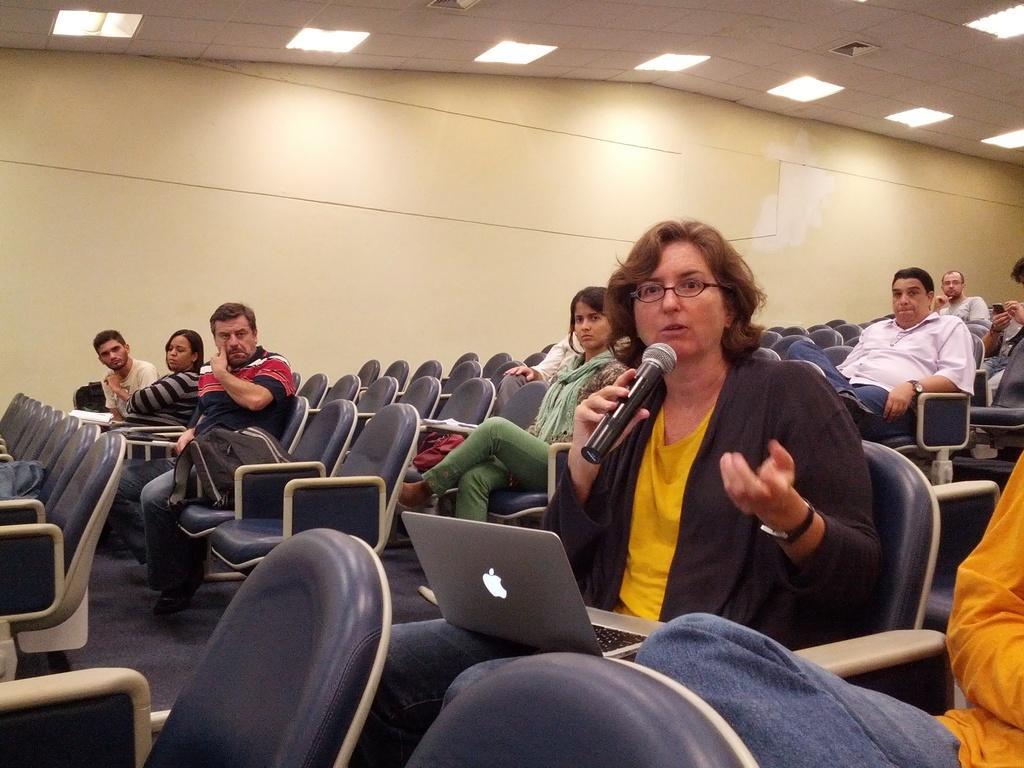Can you describe this image briefly? Here in this picture we see a conference room full of chairs present over there and we can see number of people sitting on chairs over there and in the front we can see a woman sitting on the chair with laptop on her and she is speaking something in the microphone resent in her hand and on the roof we can see lights all over there. 